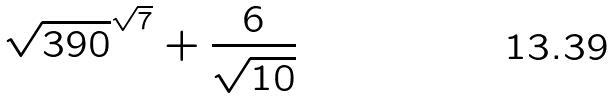Convert formula to latex. <formula><loc_0><loc_0><loc_500><loc_500>\sqrt { 3 9 0 } ^ { \sqrt { 7 } } + \frac { 6 } { \sqrt { 1 0 } }</formula> 